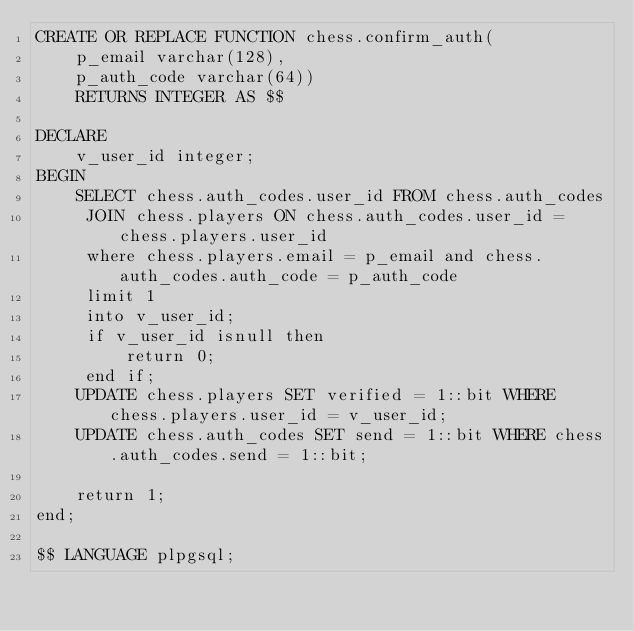Convert code to text. <code><loc_0><loc_0><loc_500><loc_500><_SQL_>CREATE OR REPLACE FUNCTION chess.confirm_auth(
	p_email varchar(128),
	p_auth_code varchar(64))
	RETURNS INTEGER AS $$

DECLARE
    v_user_id integer;
BEGIN
    SELECT chess.auth_codes.user_id FROM chess.auth_codes
     JOIN chess.players ON chess.auth_codes.user_id = chess.players.user_id
     where chess.players.email = p_email and chess.auth_codes.auth_code = p_auth_code
     limit 1
     into v_user_id;
     if v_user_id isnull then
         return 0;
     end if;
    UPDATE chess.players SET verified = 1::bit WHERE chess.players.user_id = v_user_id;
    UPDATE chess.auth_codes SET send = 1::bit WHERE chess.auth_codes.send = 1::bit;

    return 1;
end;

$$ LANGUAGE plpgsql;</code> 